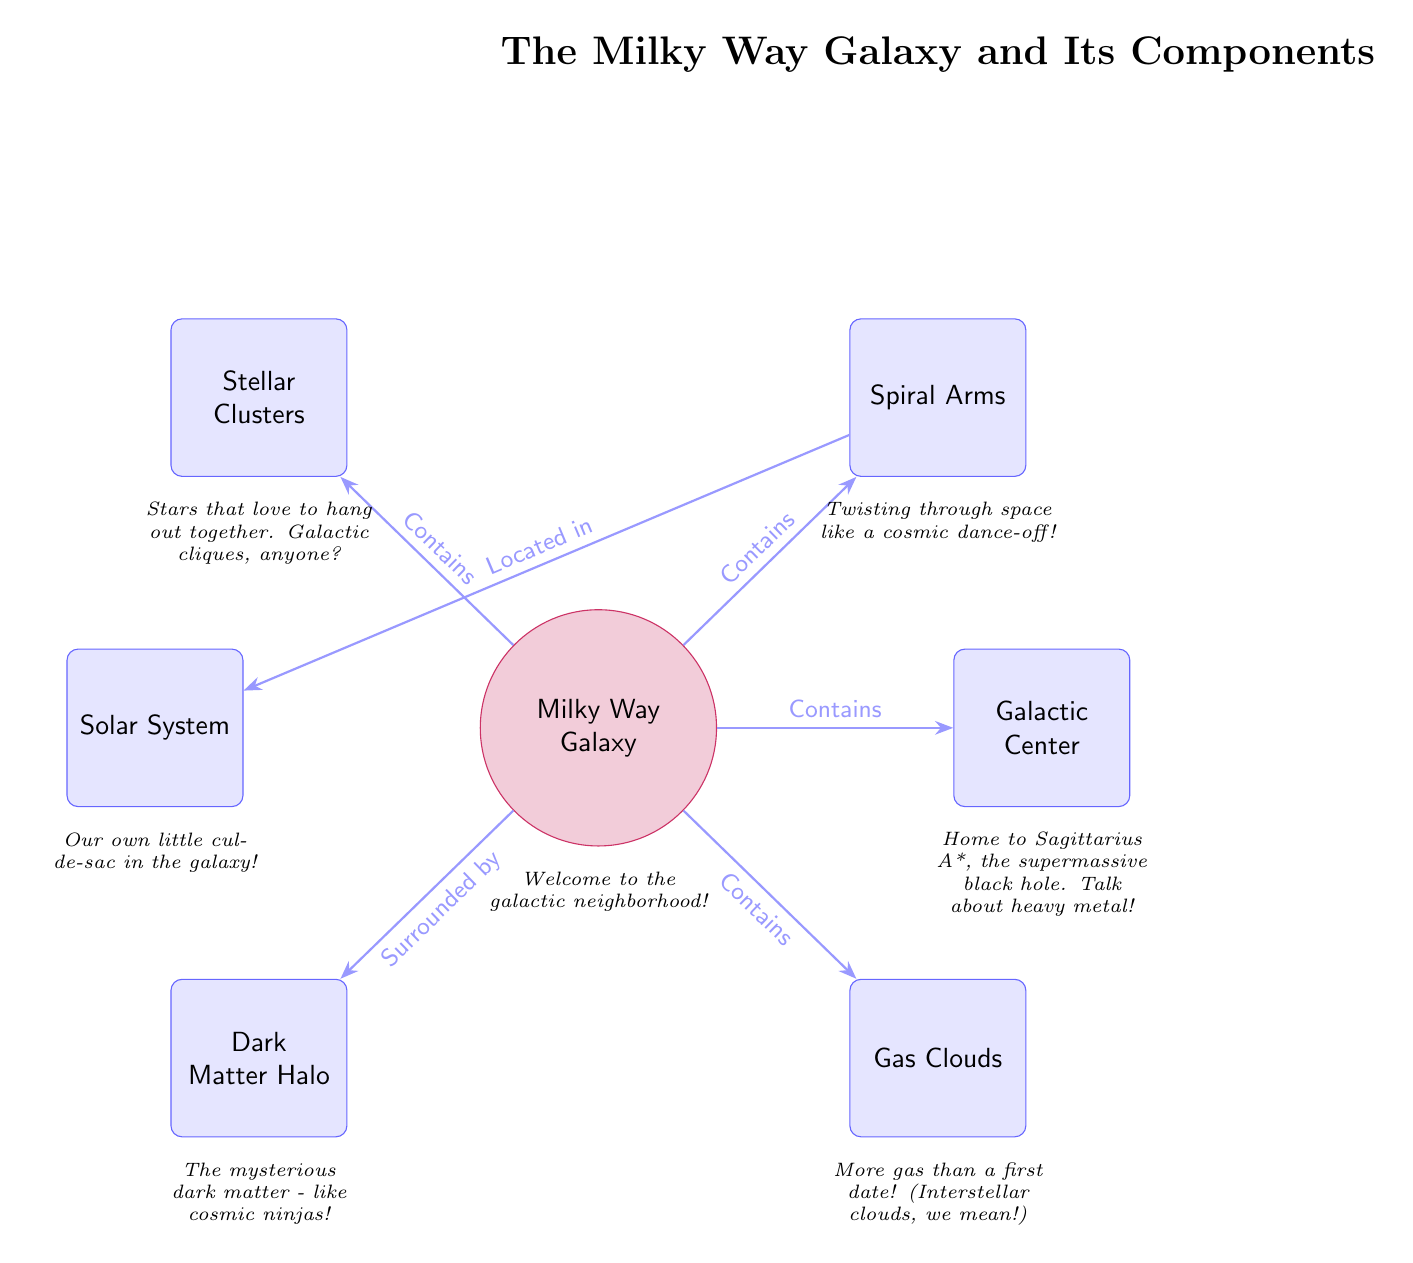What is at the center of the Milky Way Galaxy? The diagram indicates that the Galactic Center is at the center of the Milky Way Galaxy, which is clearly labeled.
Answer: Galactic Center What surrounds the Milky Way Galaxy? The diagram shows a connection from the Milky Way to the Dark Matter Halo, indicating that this halo surrounds the galaxy as labeled in the diagram.
Answer: Dark Matter Halo How many main components are highlighted in the diagram? By counting the labeled components (Spiral Arms, Galactic Center, Gas Clouds, Stellar Clusters, Solar System, Dark Matter Halo), we find there are six components shown.
Answer: 6 Which component contains Sagittarius A*? The diagram indicates that the Galactic Center contains Sagittarius A*, which is described in the caption for the Galactic Center.
Answer: Galactic Center What kind of clouds are mentioned in the diagram? The Gas Clouds component is identified in the diagram, and the caption humorously describes them as 'more gas than a first date,' clearly indicating the type of clouds referred to.
Answer: Gas Clouds Which components are directly connected to the Solar System? The diagram shows that the Solar System is connected to the Spiral Arms, which is the only other component directly related to it according to the displayed edges.
Answer: Spiral Arms What relationship does the Spiral Arms have with the Milky Way? The diagram shows that the Spiral Arms are contained within the Milky Way Galaxy, which is represented by the connection arrow pointing towards the Spiral Arms component.
Answer: Contains What do stellar clusters represent in the diagram? The Stellar Clusters component signifies groups of stars that share an affinity for being together, as indicated by the diagram's description 'stars that love to hang out together.'
Answer: Groups of stars What figure of speech is used in the caption for the dark matter halo? The caption humorously calls dark matter 'cosmic ninjas,' suggesting an elusive and mysterious quality to it, which fits well with the context of dark matter.
Answer: Cosmic ninjas 